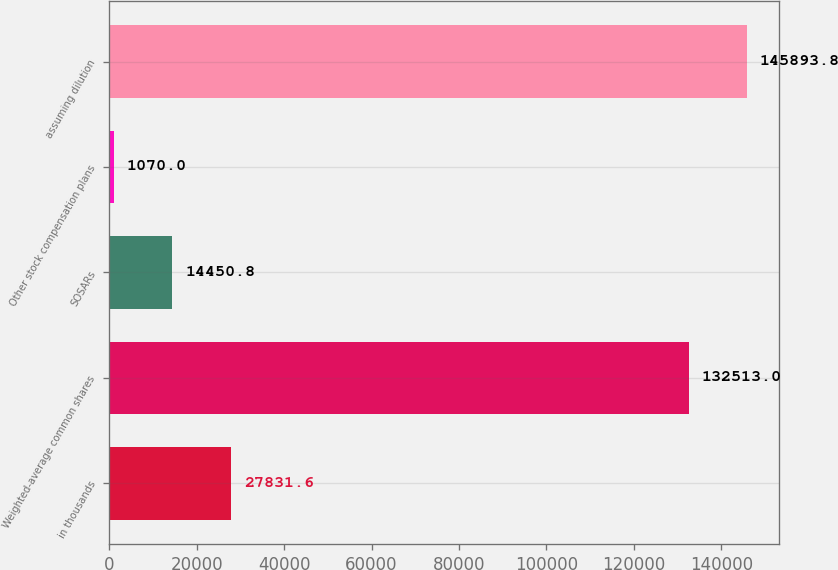Convert chart to OTSL. <chart><loc_0><loc_0><loc_500><loc_500><bar_chart><fcel>in thousands<fcel>Weighted-average common shares<fcel>SOSARs<fcel>Other stock compensation plans<fcel>assuming dilution<nl><fcel>27831.6<fcel>132513<fcel>14450.8<fcel>1070<fcel>145894<nl></chart> 